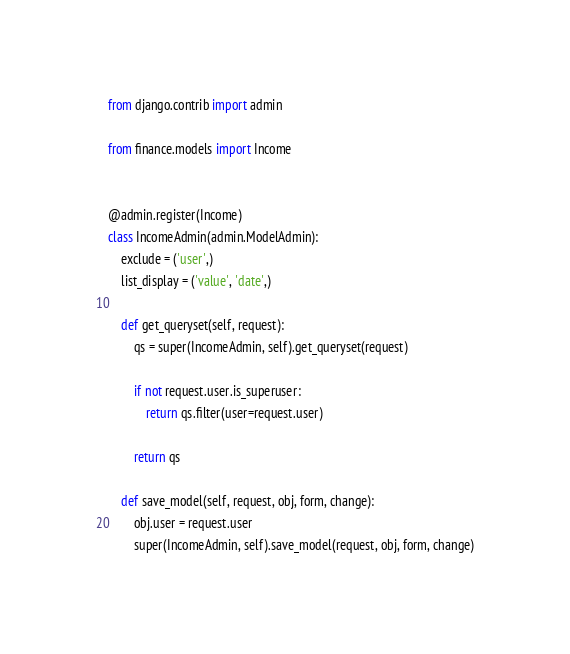Convert code to text. <code><loc_0><loc_0><loc_500><loc_500><_Python_>
from django.contrib import admin

from finance.models import Income


@admin.register(Income)
class IncomeAdmin(admin.ModelAdmin):
    exclude = ('user',)
    list_display = ('value', 'date',)

    def get_queryset(self, request):
        qs = super(IncomeAdmin, self).get_queryset(request)

        if not request.user.is_superuser:
            return qs.filter(user=request.user)

        return qs

    def save_model(self, request, obj, form, change):
        obj.user = request.user
        super(IncomeAdmin, self).save_model(request, obj, form, change)
</code> 